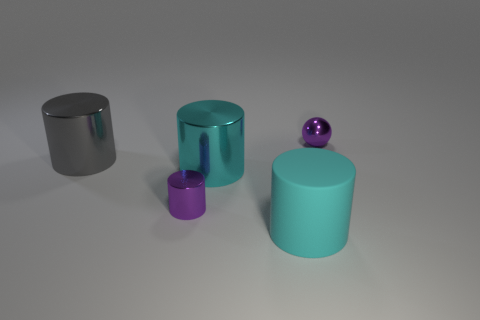Subtract 1 cylinders. How many cylinders are left? 3 Subtract all brown cylinders. Subtract all red spheres. How many cylinders are left? 4 Add 4 shiny spheres. How many objects exist? 9 Subtract all cylinders. How many objects are left? 1 Add 1 tiny purple objects. How many tiny purple objects are left? 3 Add 3 large red rubber cylinders. How many large red rubber cylinders exist? 3 Subtract 1 gray cylinders. How many objects are left? 4 Subtract all big brown blocks. Subtract all cyan metallic cylinders. How many objects are left? 4 